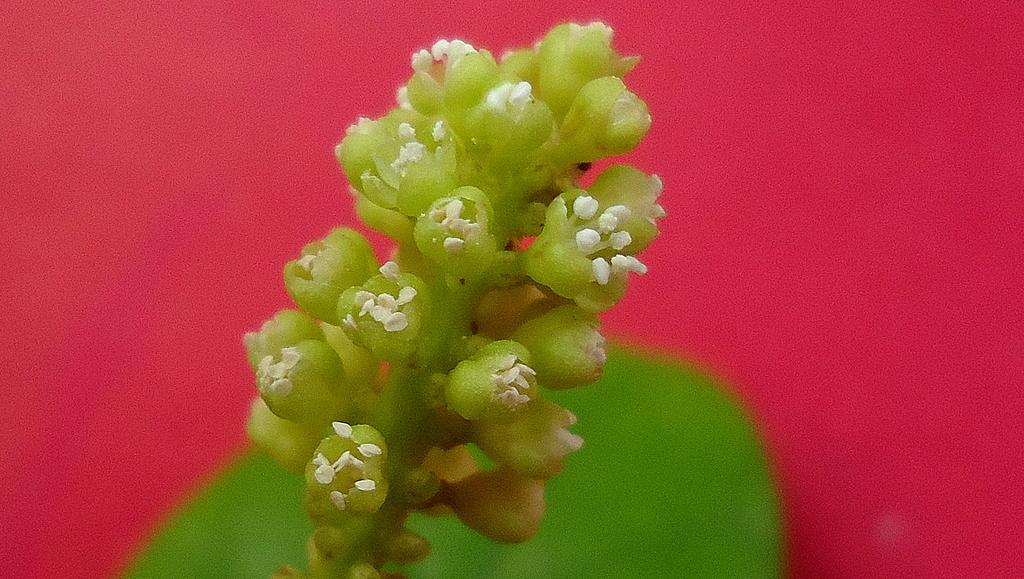What is present in the image? There is a plant in the picture. What can be observed about the background of the image? The background of the image is red in color. What type of lace can be seen on the plant in the image? There is no lace present on the plant in the image. What is the texture of the plant in the image? The texture of the plant cannot be determined from the image alone, as it only provides visual information. 